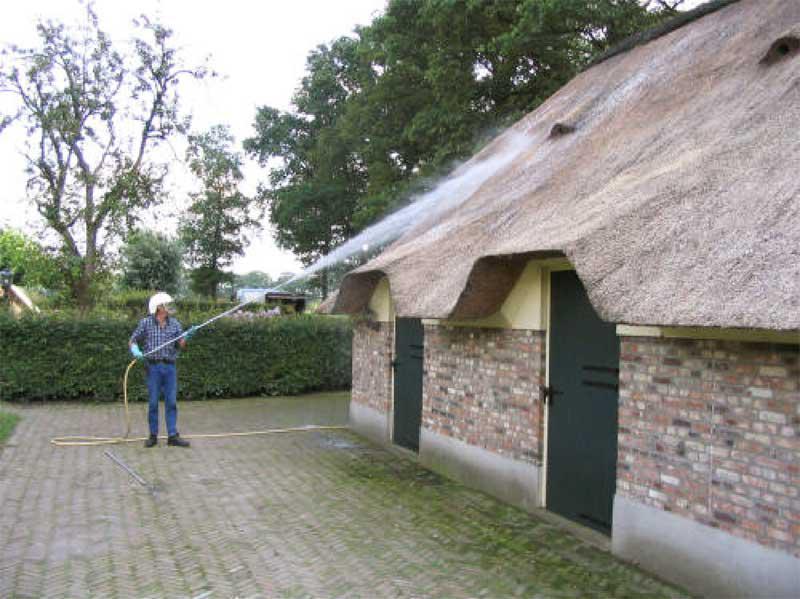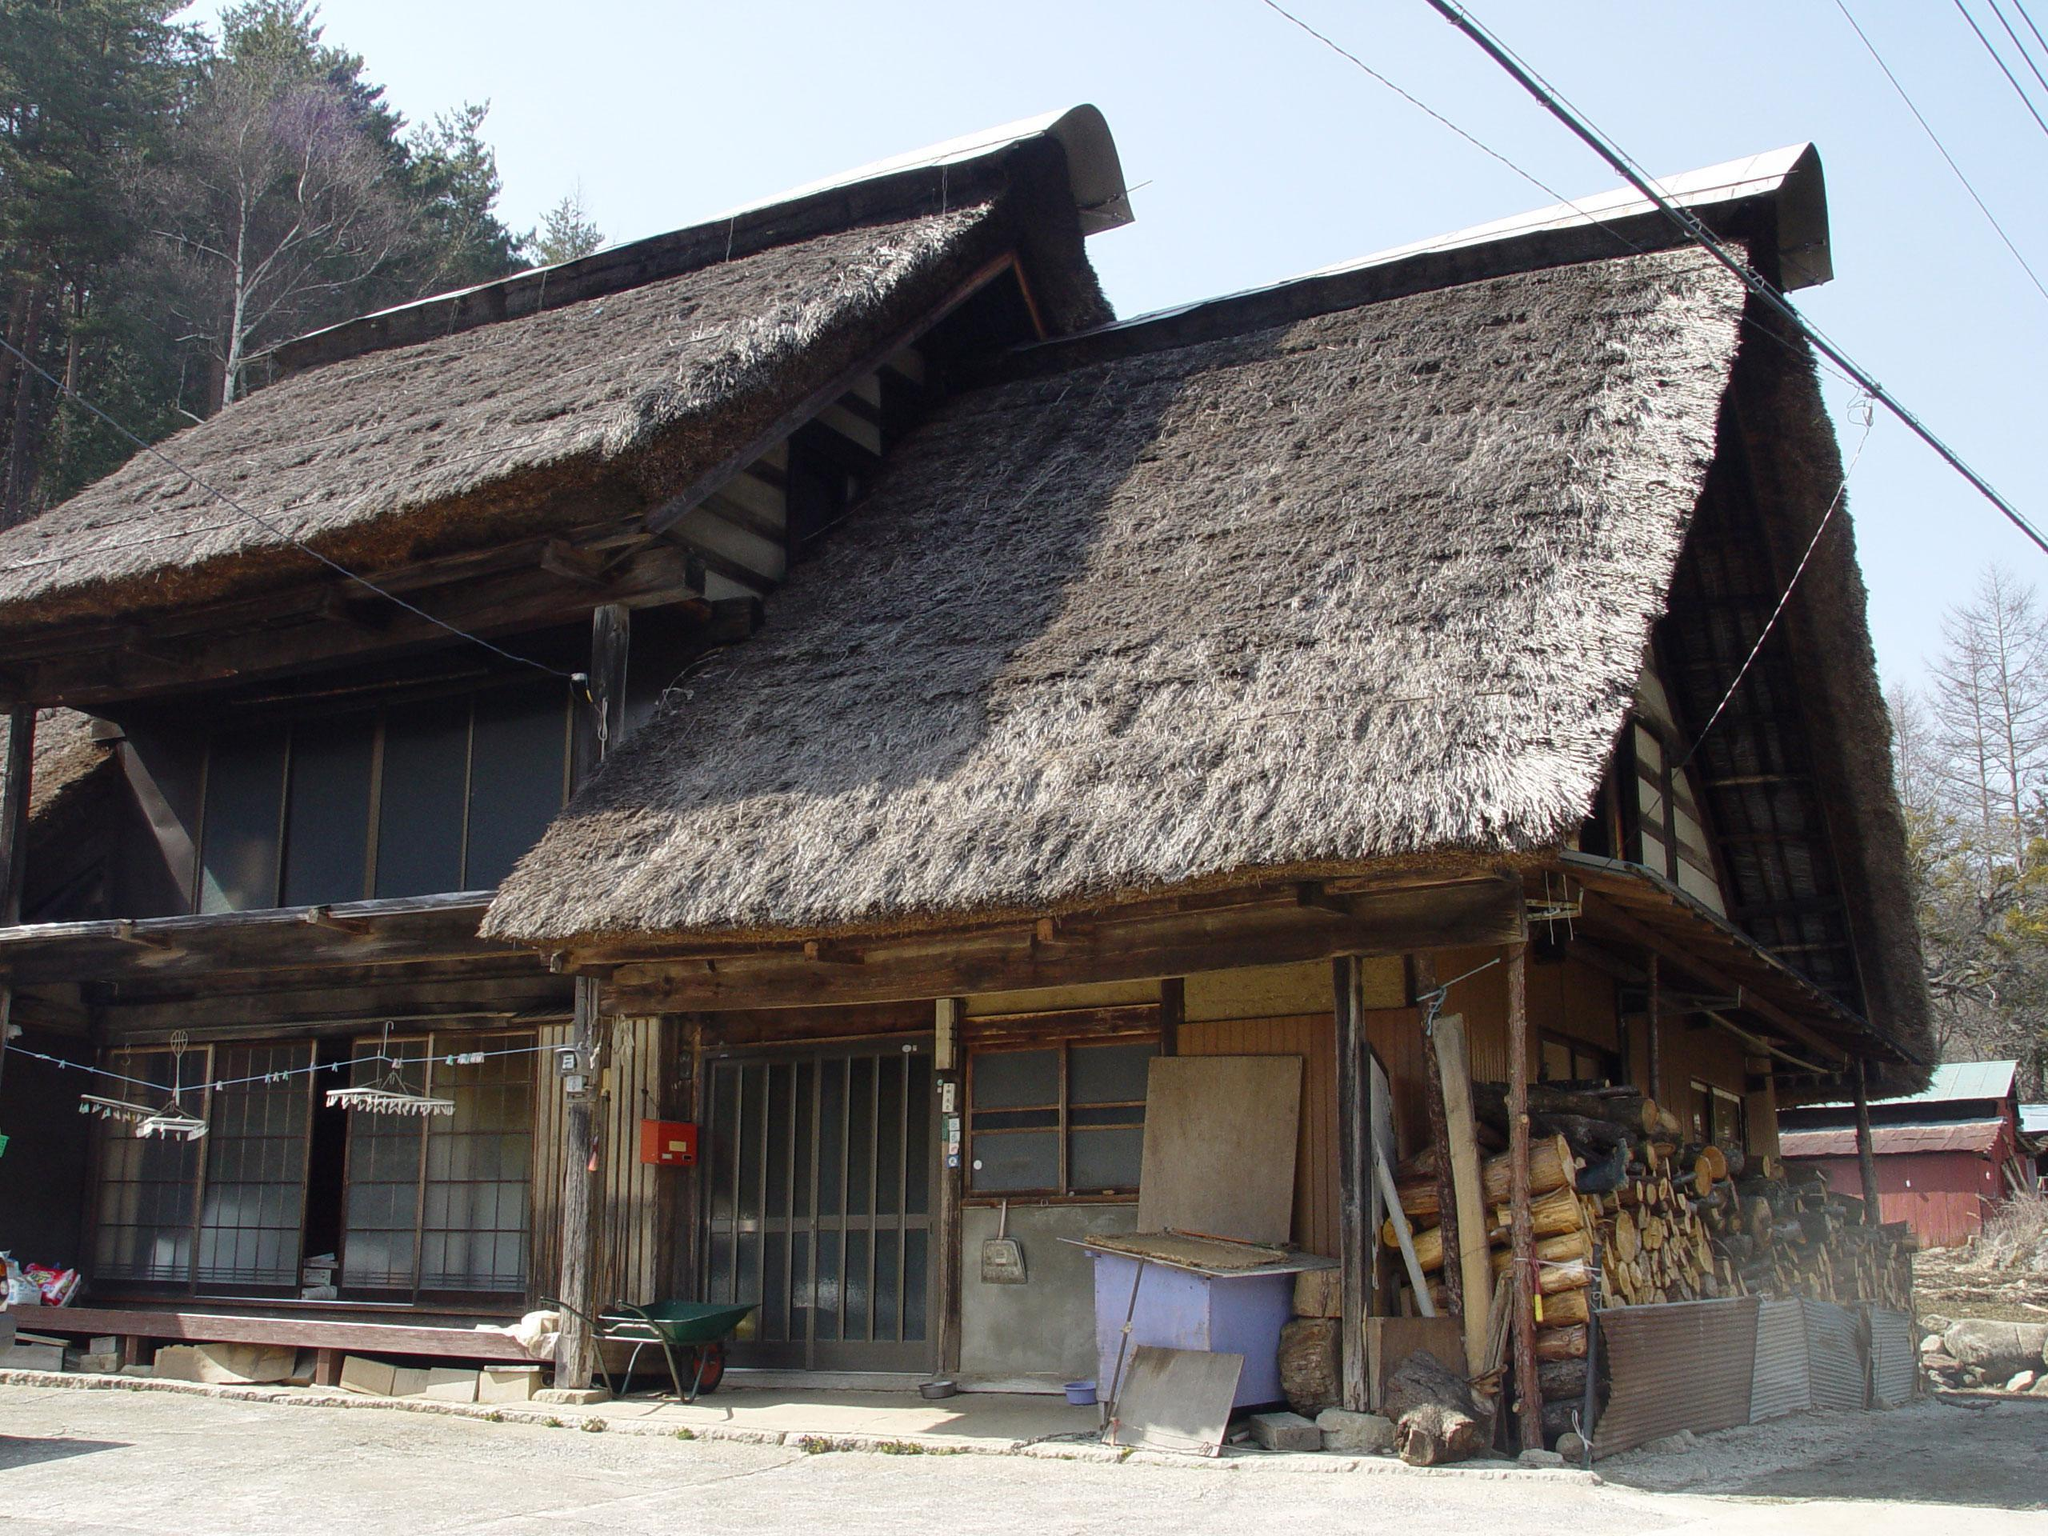The first image is the image on the left, the second image is the image on the right. Evaluate the accuracy of this statement regarding the images: "A building facing leftward has a long thatched roof with two notches on the bottom made to accommodate a door or window.". Is it true? Answer yes or no. Yes. The first image is the image on the left, the second image is the image on the right. Assess this claim about the two images: "In at least one image there is a white house with black angle strips on it.". Correct or not? Answer yes or no. No. 